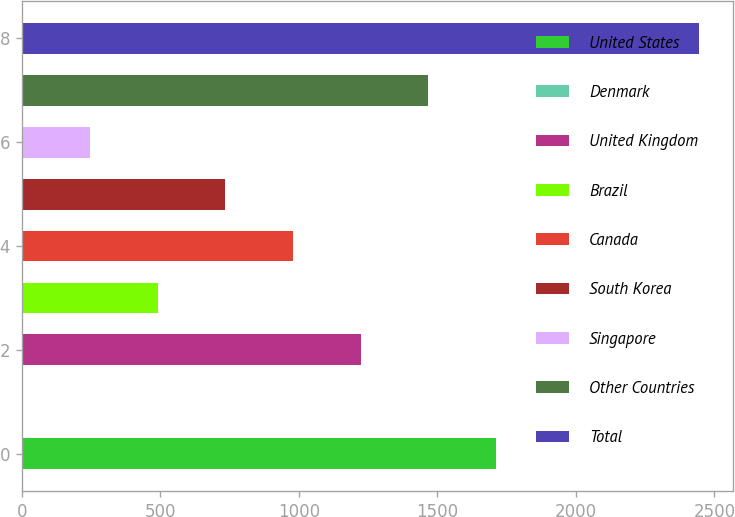Convert chart. <chart><loc_0><loc_0><loc_500><loc_500><bar_chart><fcel>United States<fcel>Denmark<fcel>United Kingdom<fcel>Brazil<fcel>Canada<fcel>South Korea<fcel>Singapore<fcel>Other Countries<fcel>Total<nl><fcel>1712.4<fcel>3<fcel>1224<fcel>491.4<fcel>979.8<fcel>735.6<fcel>247.2<fcel>1468.2<fcel>2445<nl></chart> 